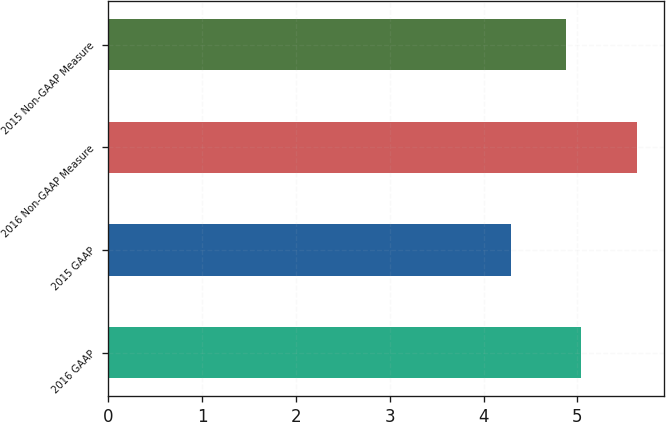Convert chart. <chart><loc_0><loc_0><loc_500><loc_500><bar_chart><fcel>2016 GAAP<fcel>2015 GAAP<fcel>2016 Non-GAAP Measure<fcel>2015 Non-GAAP Measure<nl><fcel>5.04<fcel>4.29<fcel>5.64<fcel>4.88<nl></chart> 